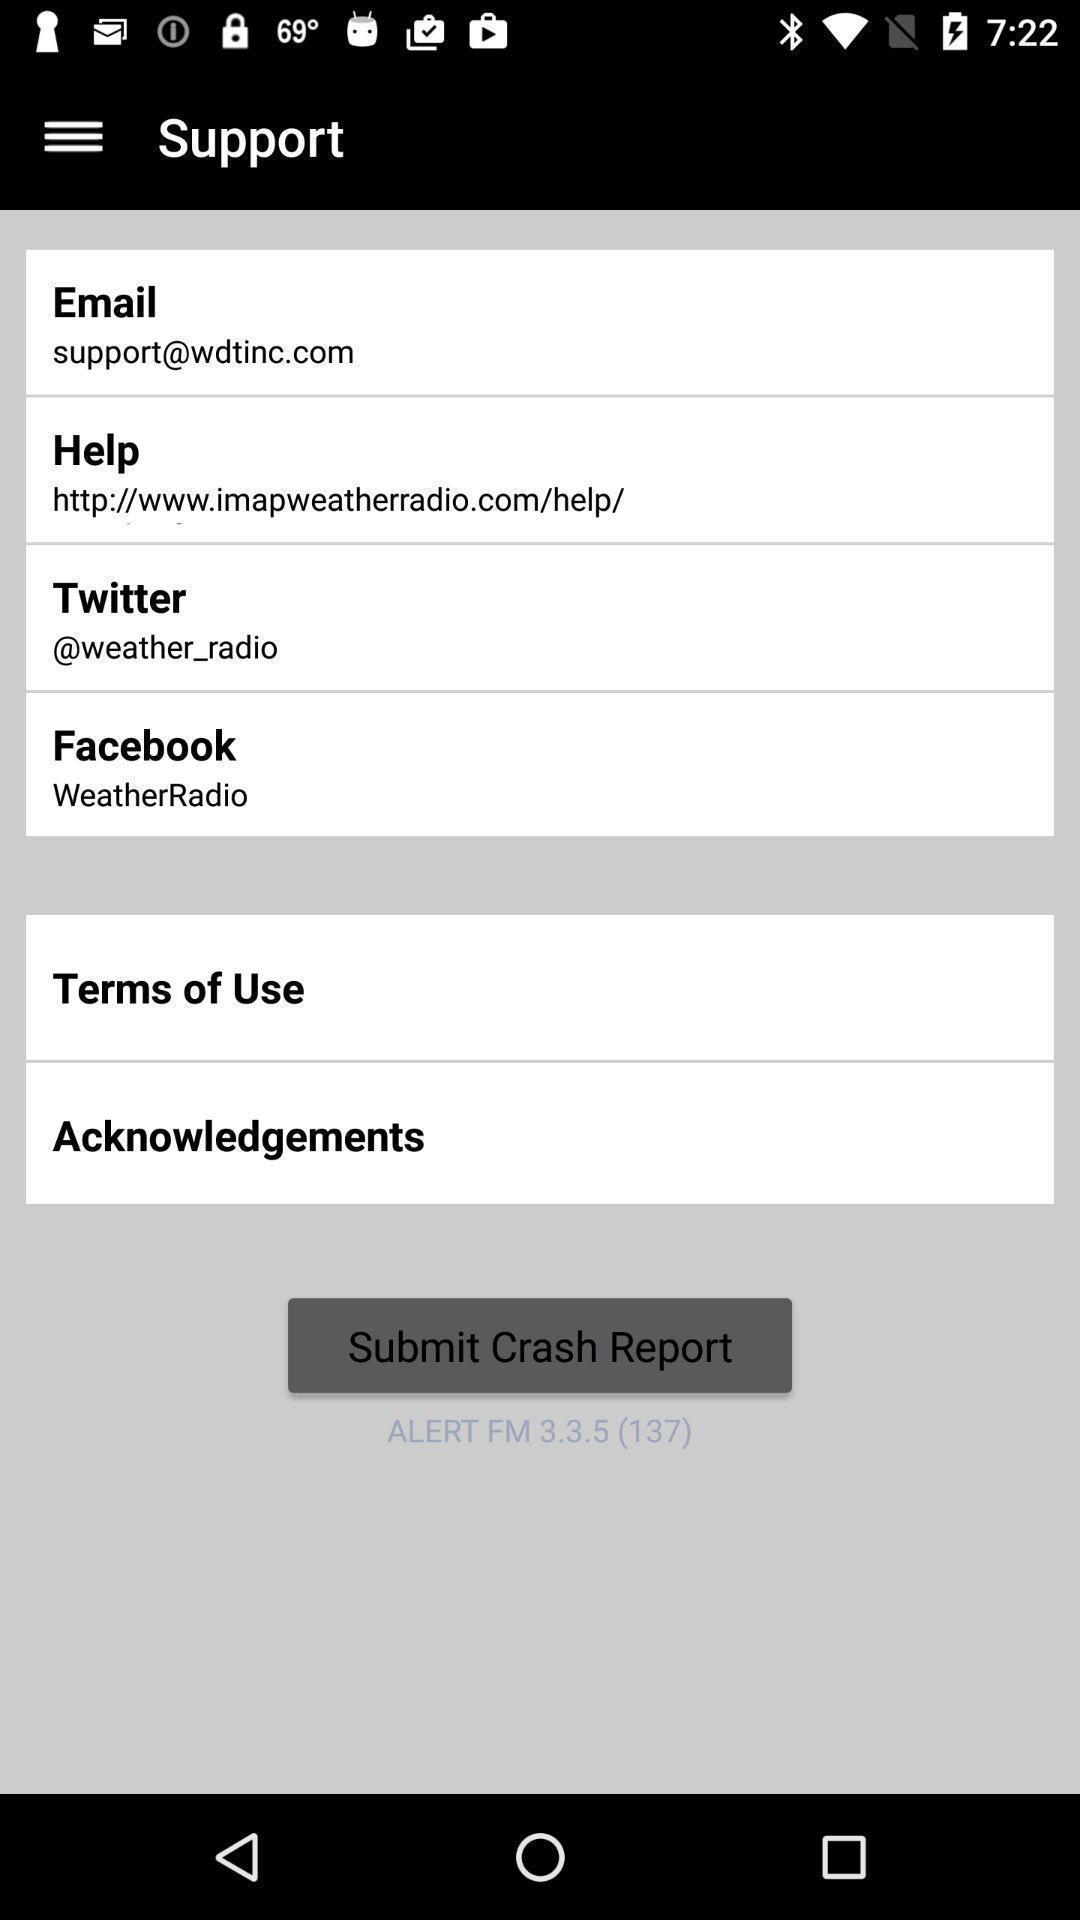Give me a summary of this screen capture. Support tab in the application with some options. 